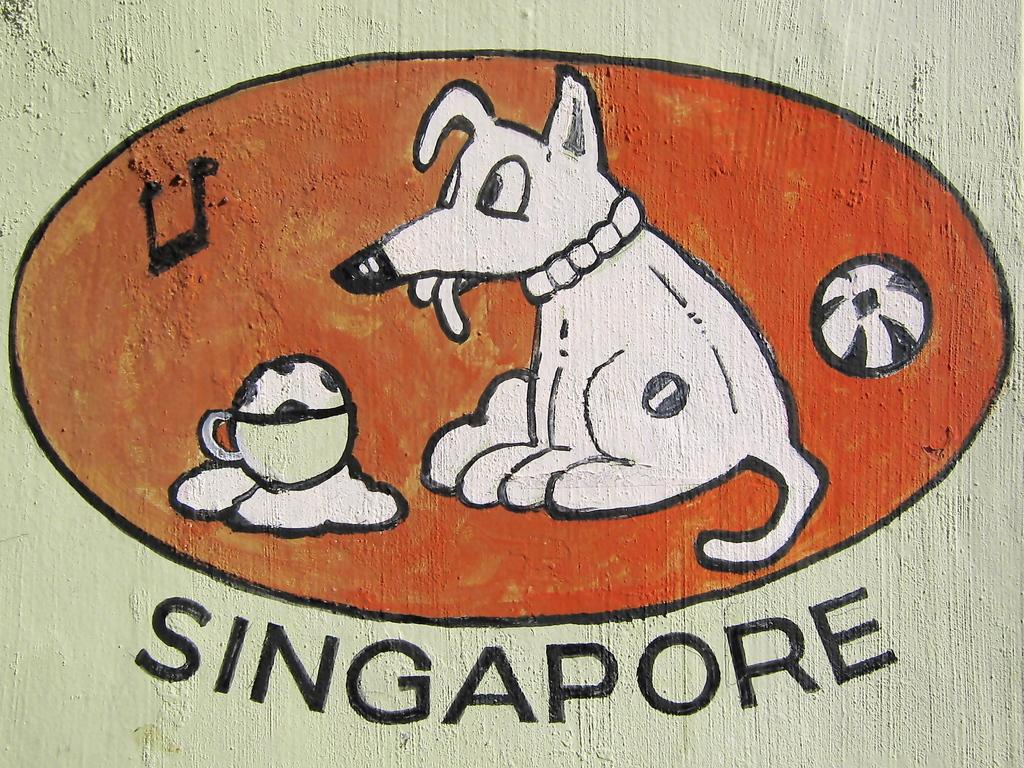What is the main subject of the image? There is a painting in the image. What objects are depicted in the painting? The painting contains pictures of a dog, a cup, and a ball. What type of song is being played by the grandfather on the bike in the image? There is no grandfather, bike, or song present in the image; it only features a painting with pictures of a dog, a cup, and a ball. 